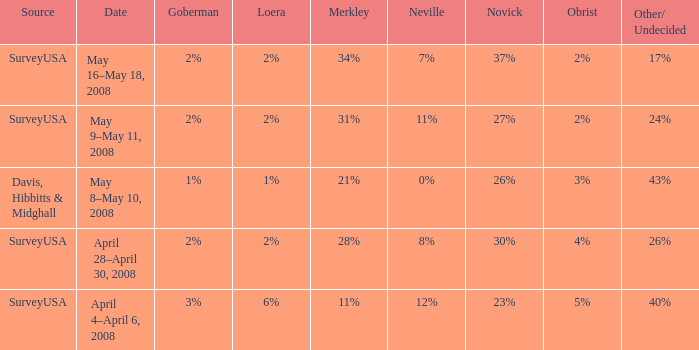Which Goberman has a Date of april 28–april 30, 2008? 2%. 